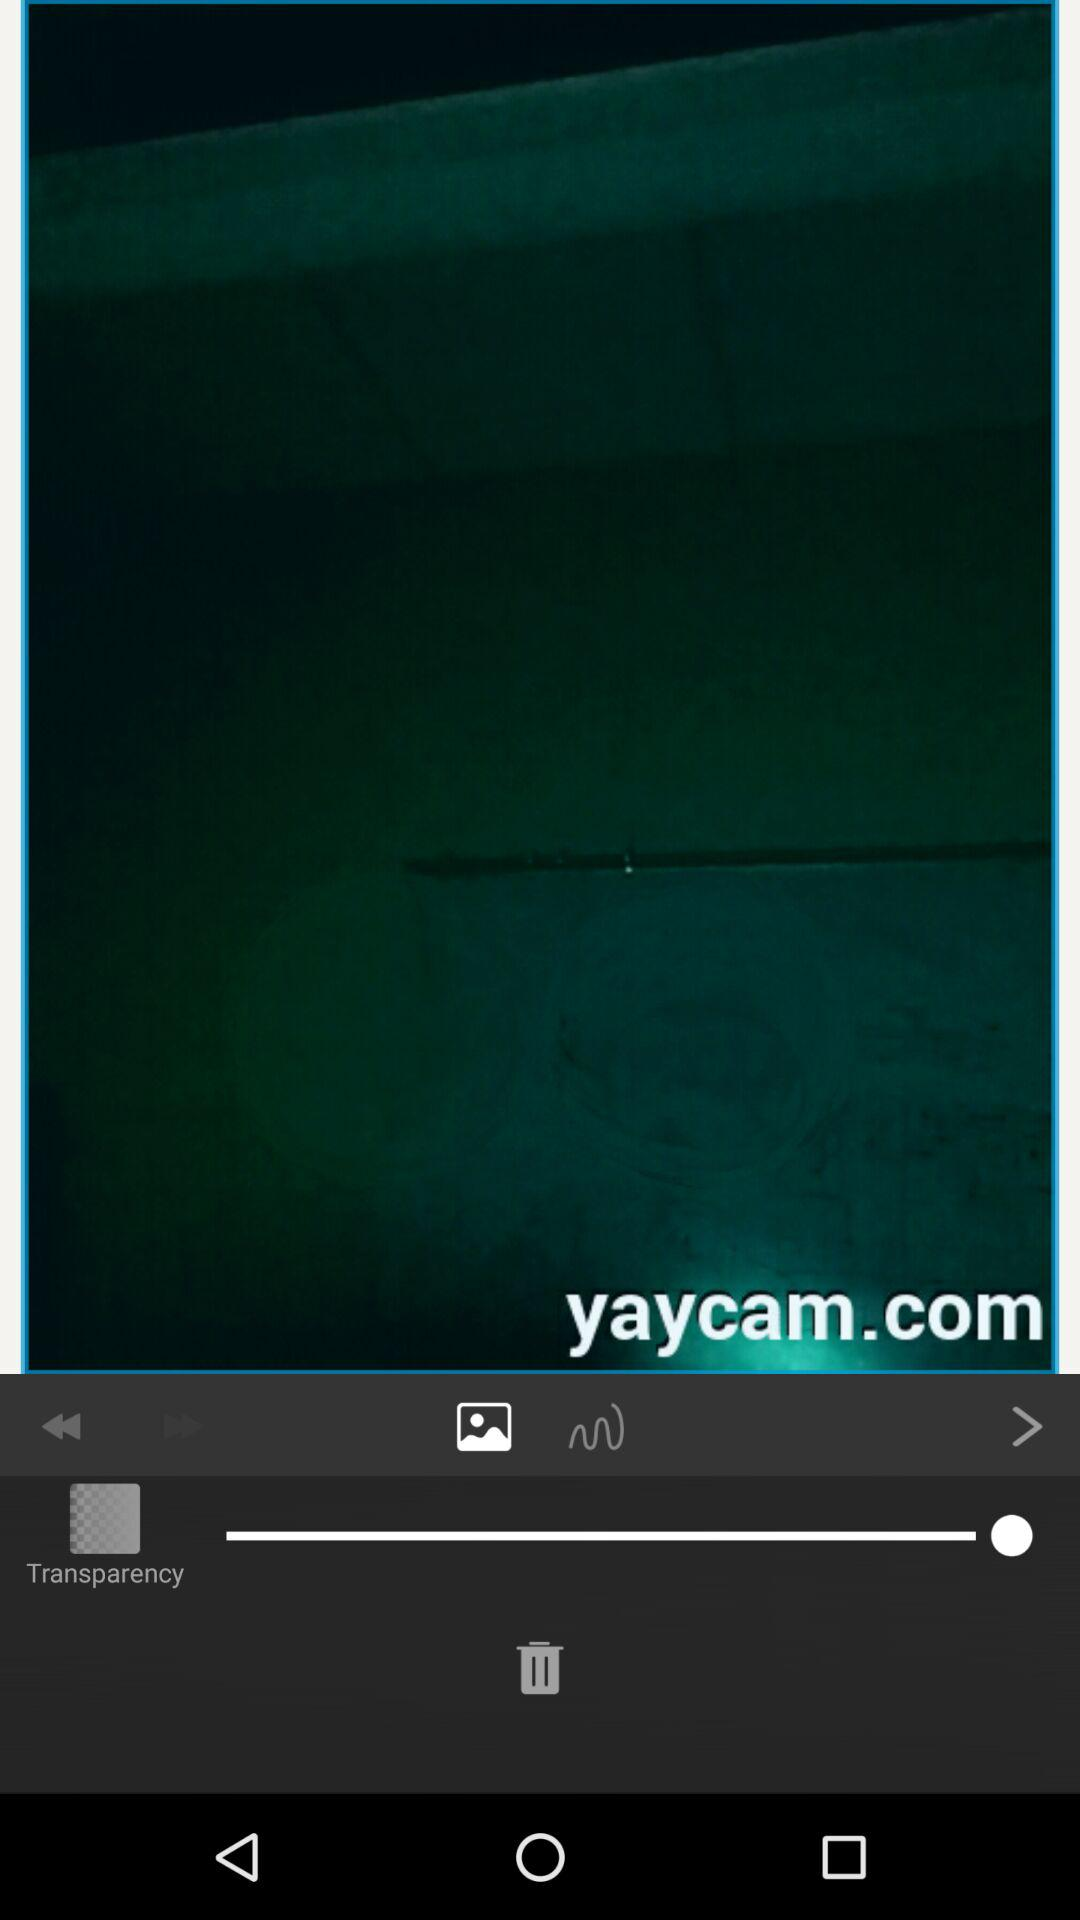What is the name of the website? The name of the website is yaycam.com. 